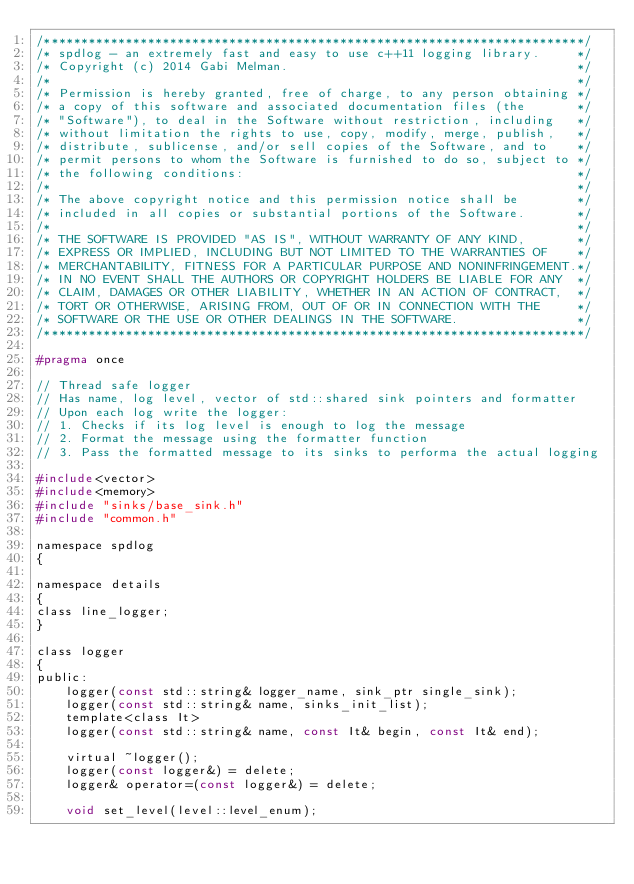Convert code to text. <code><loc_0><loc_0><loc_500><loc_500><_C_>/*************************************************************************/
/* spdlog - an extremely fast and easy to use c++11 logging library.     */
/* Copyright (c) 2014 Gabi Melman.                                       */
/*                                                                       */
/* Permission is hereby granted, free of charge, to any person obtaining */
/* a copy of this software and associated documentation files (the       */
/* "Software"), to deal in the Software without restriction, including   */
/* without limitation the rights to use, copy, modify, merge, publish,   */
/* distribute, sublicense, and/or sell copies of the Software, and to    */
/* permit persons to whom the Software is furnished to do so, subject to */
/* the following conditions:                                             */
/*                                                                       */
/* The above copyright notice and this permission notice shall be        */
/* included in all copies or substantial portions of the Software.       */
/*                                                                       */
/* THE SOFTWARE IS PROVIDED "AS IS", WITHOUT WARRANTY OF ANY KIND,       */
/* EXPRESS OR IMPLIED, INCLUDING BUT NOT LIMITED TO THE WARRANTIES OF    */
/* MERCHANTABILITY, FITNESS FOR A PARTICULAR PURPOSE AND NONINFRINGEMENT.*/
/* IN NO EVENT SHALL THE AUTHORS OR COPYRIGHT HOLDERS BE LIABLE FOR ANY  */
/* CLAIM, DAMAGES OR OTHER LIABILITY, WHETHER IN AN ACTION OF CONTRACT,  */
/* TORT OR OTHERWISE, ARISING FROM, OUT OF OR IN CONNECTION WITH THE     */
/* SOFTWARE OR THE USE OR OTHER DEALINGS IN THE SOFTWARE.                */
/*************************************************************************/

#pragma once

// Thread safe logger
// Has name, log level, vector of std::shared sink pointers and formatter
// Upon each log write the logger:
// 1. Checks if its log level is enough to log the message
// 2. Format the message using the formatter function
// 3. Pass the formatted message to its sinks to performa the actual logging

#include<vector>
#include<memory>
#include "sinks/base_sink.h"
#include "common.h"

namespace spdlog
{

namespace details
{
class line_logger;
}

class logger
{
public:
    logger(const std::string& logger_name, sink_ptr single_sink);
    logger(const std::string& name, sinks_init_list);
    template<class It>
    logger(const std::string& name, const It& begin, const It& end);

    virtual ~logger();
    logger(const logger&) = delete;
    logger& operator=(const logger&) = delete;

    void set_level(level::level_enum);</code> 